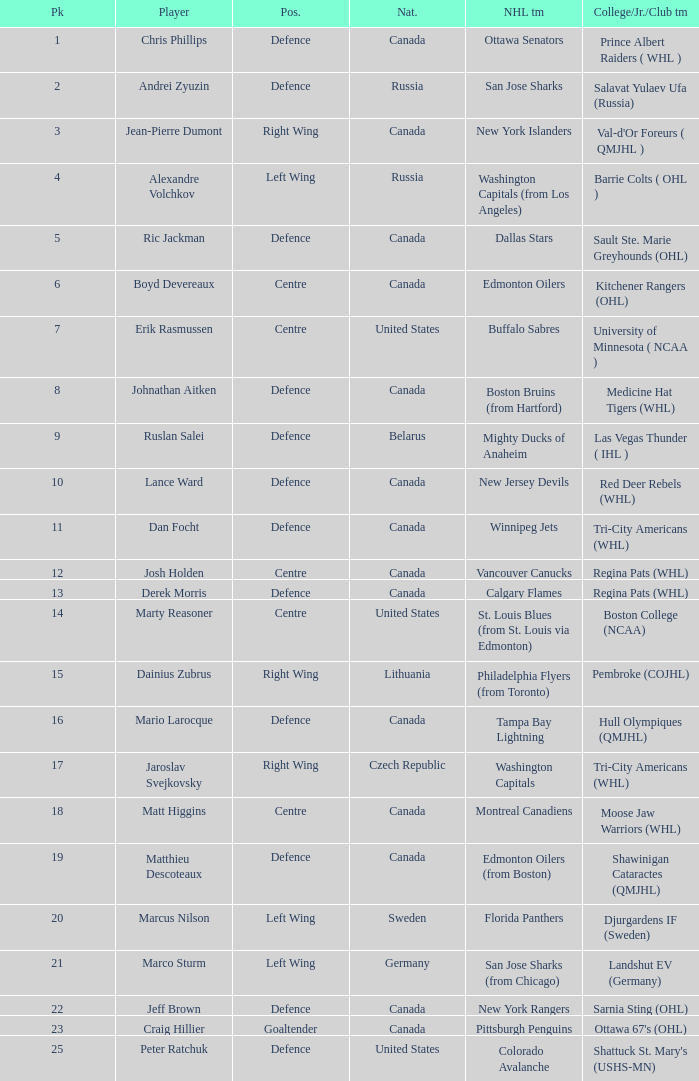How many positions does the draft pick whose nationality is Czech Republic play? 1.0. 